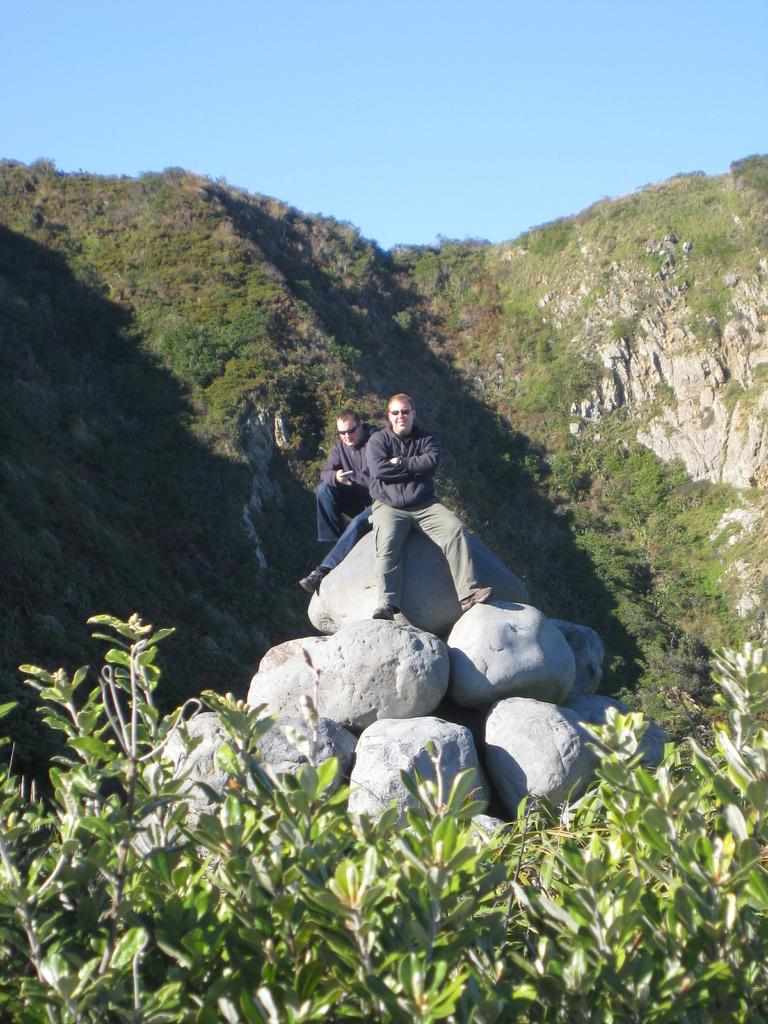What are the two people in the image doing? The two people are sitting on stones in the image. What type of natural landscape can be seen in the image? Mountains are visible in the image. What type of vegetation is present in the image? Green plants are present in the image. What event is the achiever attending in the image? There is no event or achiever present in the image; it features two people sitting on stones with mountains and green plants in the background. 